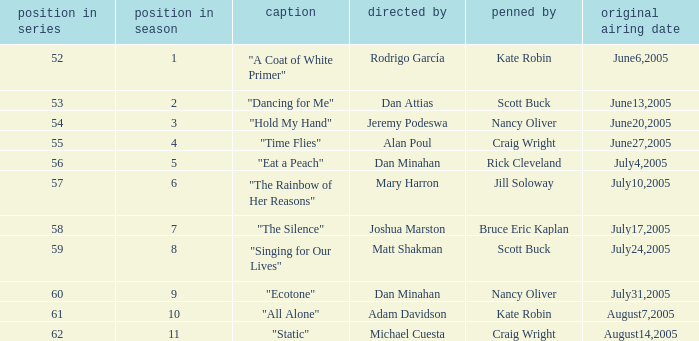What date was episode 10 in the season originally aired? August7,2005. 